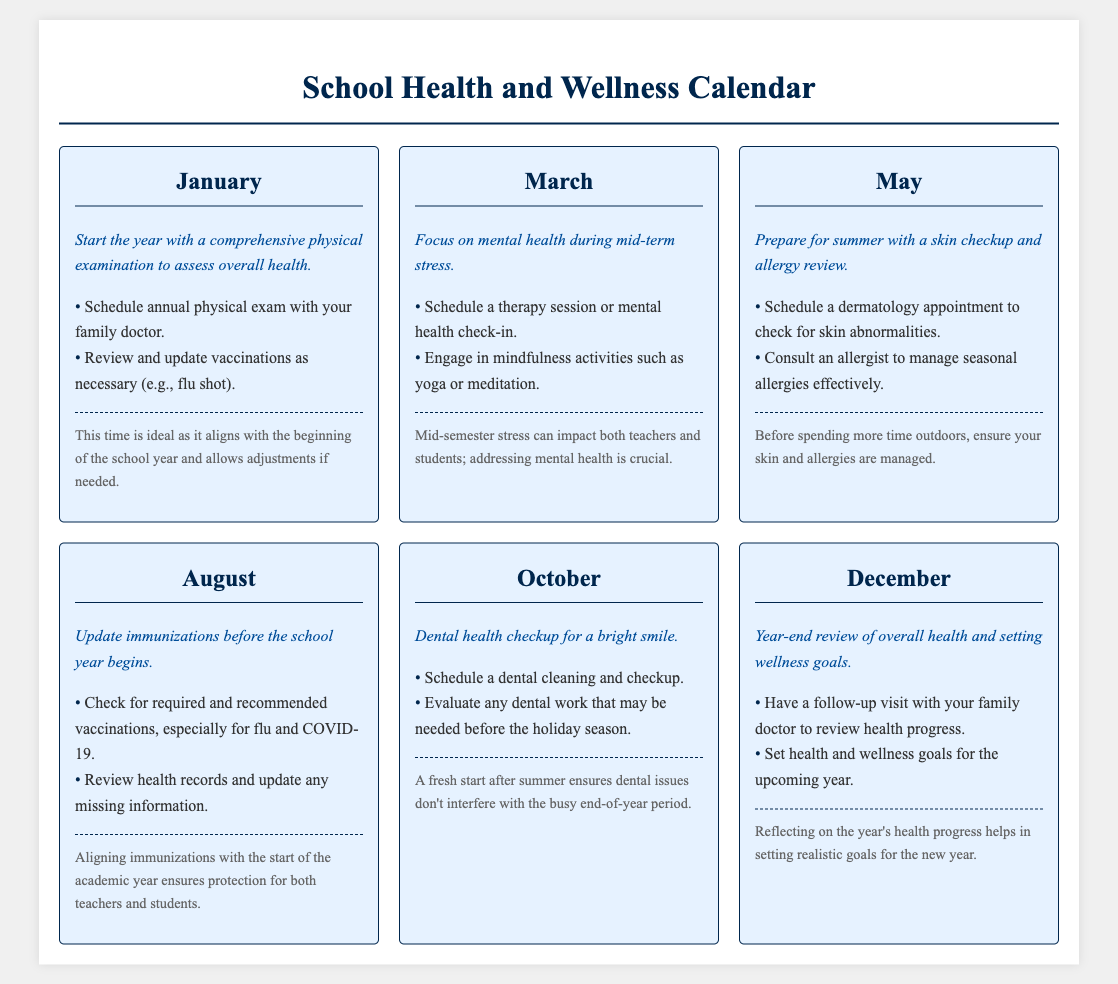What month is suggested for a comprehensive physical examination? The document indicates January as the month for a comprehensive physical examination to assess overall health.
Answer: January What is one recommended action for March? The document specifies scheduling a therapy session or mental health check-in as a recommended action in March.
Answer: Schedule a therapy session Which month advises updating immunizations? According to the document, August is the month that advises checking for required and recommended vaccinations.
Answer: August What type of health check is suggested in October? The document states that a dental health checkup is suggested in October for maintaining oral health.
Answer: Dental health checkup What overall health activity is recommended in December? The document recommends having a follow-up visit with your family doctor to review health progress in December.
Answer: Follow-up visit What seasonal aspect is highlighted in May? The document focuses on preparing for summer by managing skin health and allergies in May.
Answer: Summer Which health tip is associated with mental health? The document's health tip associated with March highlights the importance of focusing on mental health during mid-term stress.
Answer: Mental health How does the document emphasize the timing for health actions? The timing for health actions aligns with the school calendar to ensure proper planning throughout the academic year, such as updates before the school year.
Answer: School calendar alignment 